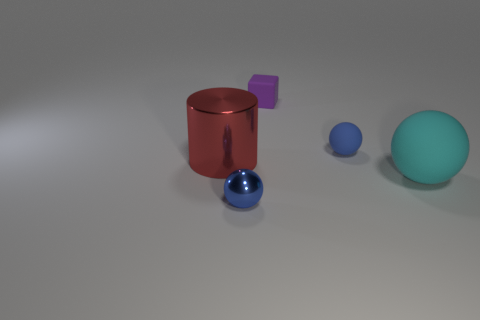Add 1 purple metal things. How many objects exist? 6 Subtract all cylinders. How many objects are left? 4 Subtract all large cyan shiny cylinders. Subtract all small purple things. How many objects are left? 4 Add 2 red cylinders. How many red cylinders are left? 3 Add 1 small rubber balls. How many small rubber balls exist? 2 Subtract 0 gray cylinders. How many objects are left? 5 